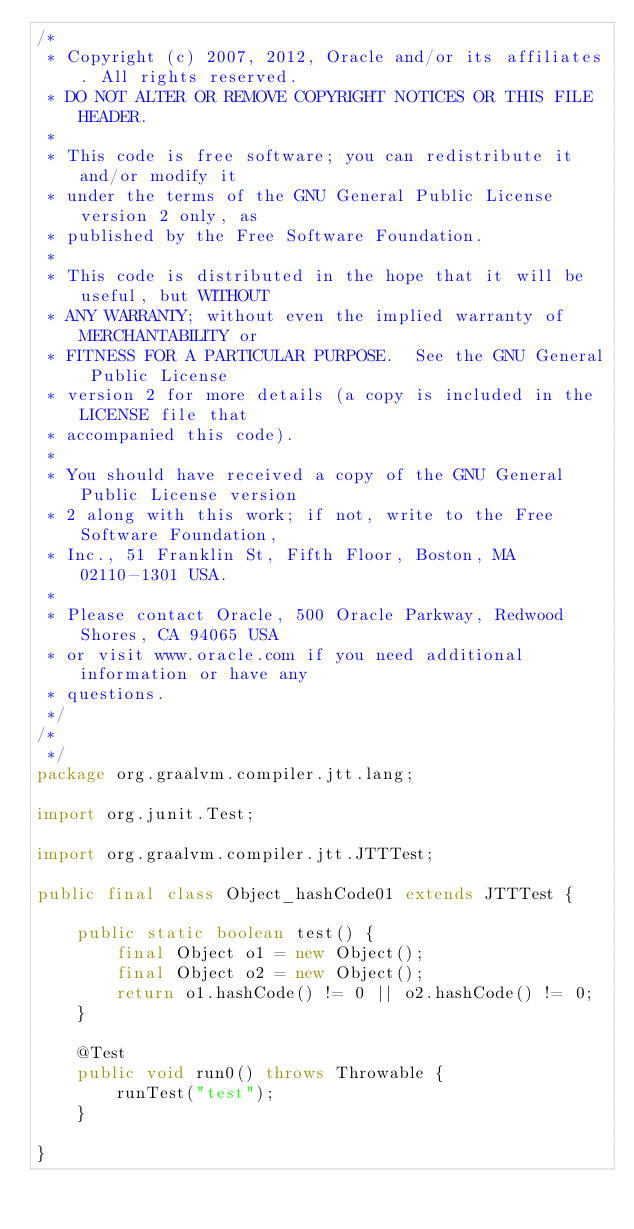<code> <loc_0><loc_0><loc_500><loc_500><_Java_>/*
 * Copyright (c) 2007, 2012, Oracle and/or its affiliates. All rights reserved.
 * DO NOT ALTER OR REMOVE COPYRIGHT NOTICES OR THIS FILE HEADER.
 *
 * This code is free software; you can redistribute it and/or modify it
 * under the terms of the GNU General Public License version 2 only, as
 * published by the Free Software Foundation.
 *
 * This code is distributed in the hope that it will be useful, but WITHOUT
 * ANY WARRANTY; without even the implied warranty of MERCHANTABILITY or
 * FITNESS FOR A PARTICULAR PURPOSE.  See the GNU General Public License
 * version 2 for more details (a copy is included in the LICENSE file that
 * accompanied this code).
 *
 * You should have received a copy of the GNU General Public License version
 * 2 along with this work; if not, write to the Free Software Foundation,
 * Inc., 51 Franklin St, Fifth Floor, Boston, MA 02110-1301 USA.
 *
 * Please contact Oracle, 500 Oracle Parkway, Redwood Shores, CA 94065 USA
 * or visit www.oracle.com if you need additional information or have any
 * questions.
 */
/*
 */
package org.graalvm.compiler.jtt.lang;

import org.junit.Test;

import org.graalvm.compiler.jtt.JTTTest;

public final class Object_hashCode01 extends JTTTest {

    public static boolean test() {
        final Object o1 = new Object();
        final Object o2 = new Object();
        return o1.hashCode() != 0 || o2.hashCode() != 0;
    }

    @Test
    public void run0() throws Throwable {
        runTest("test");
    }

}
</code> 